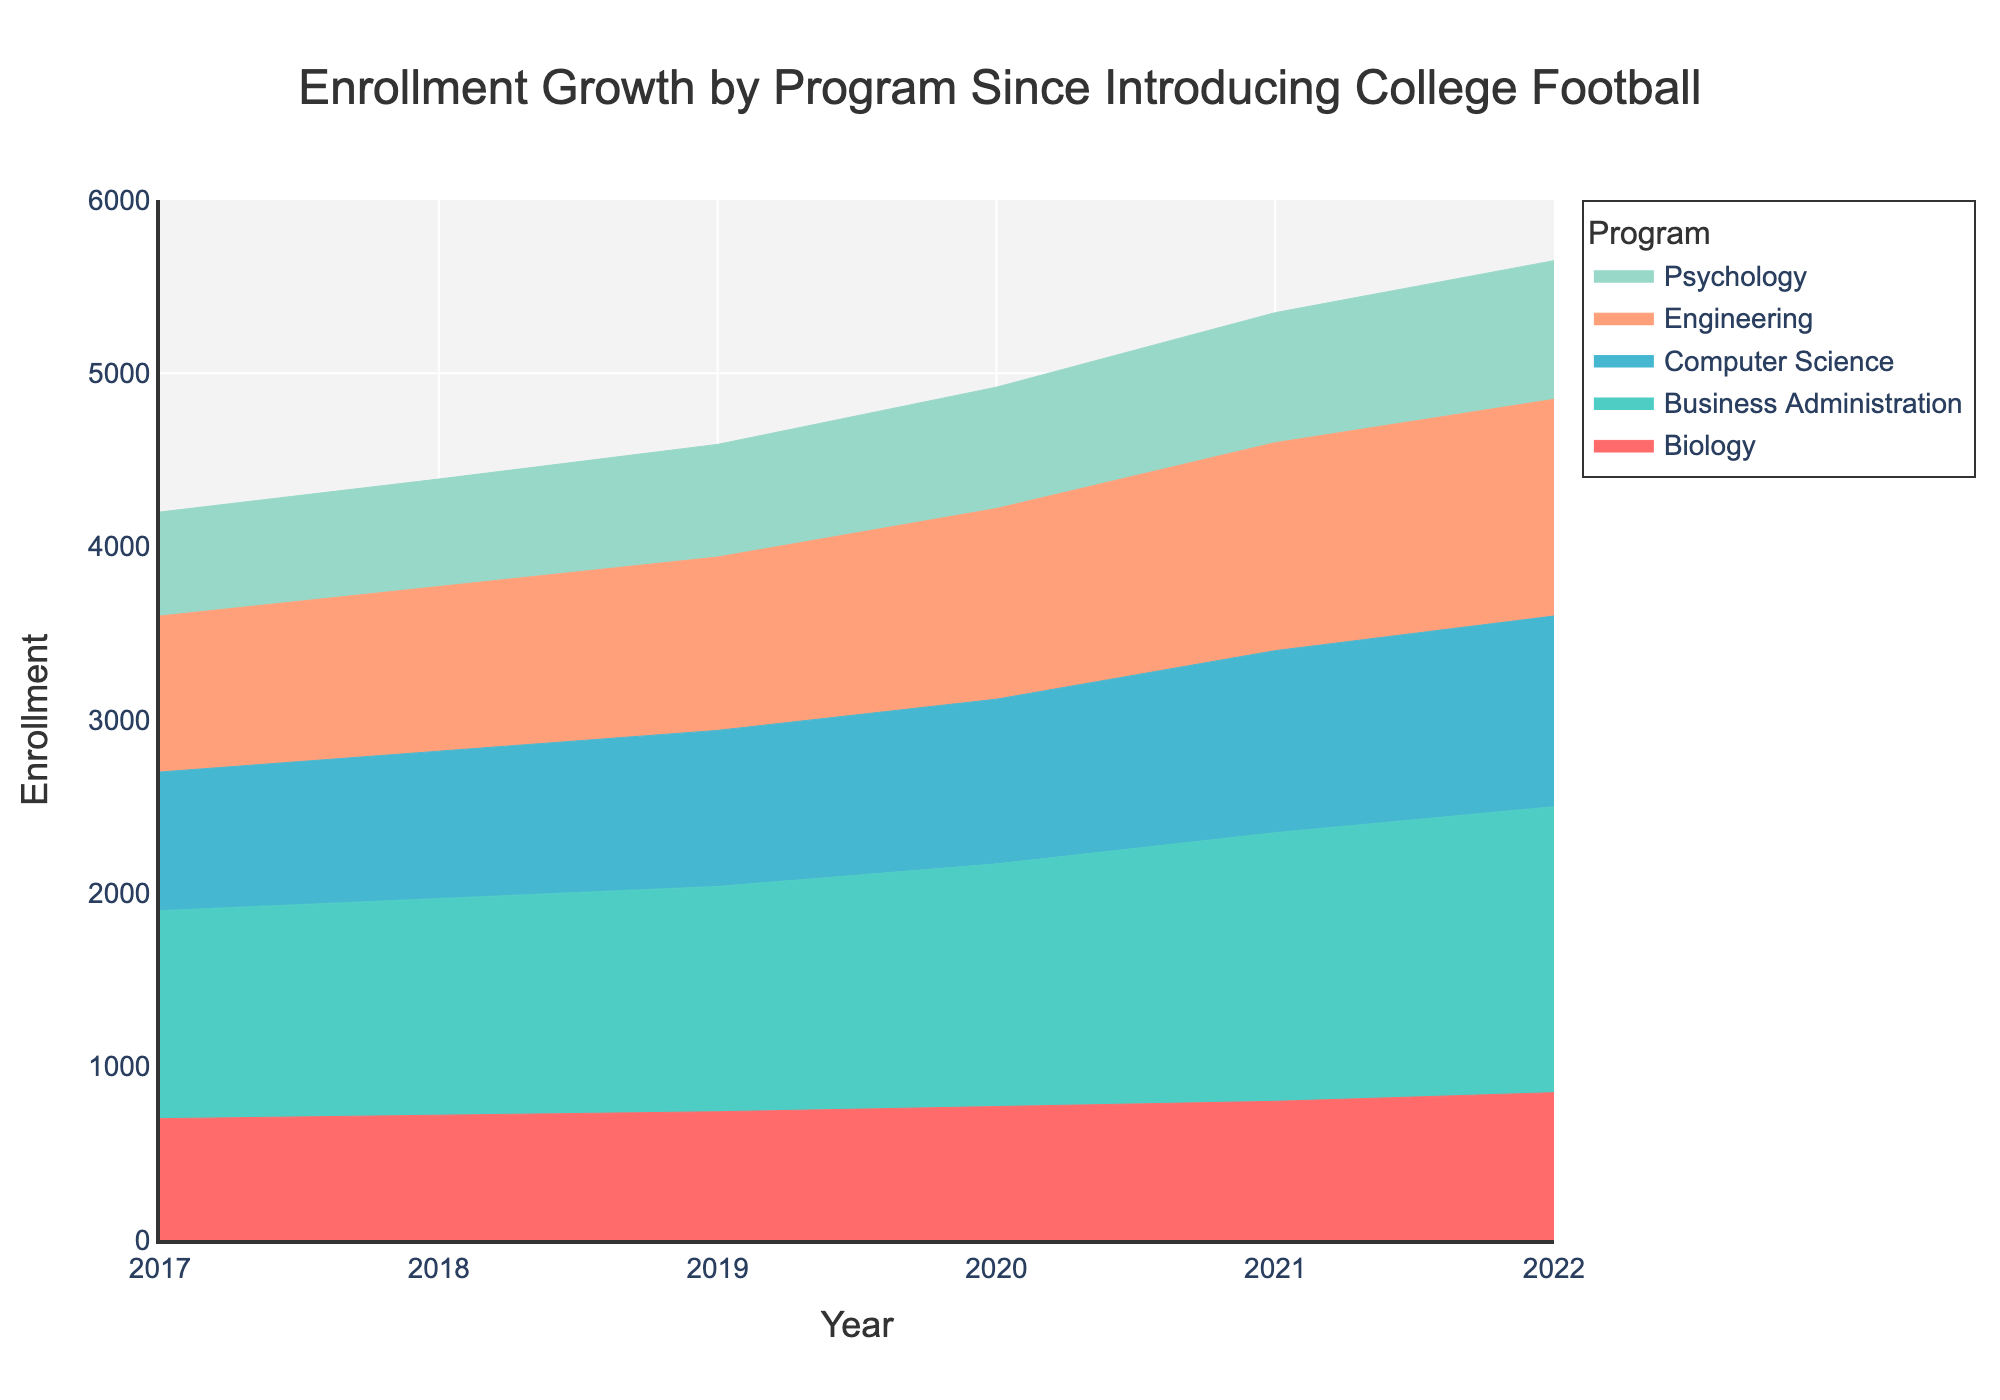What is the title of the plot? The title is usually located at the top of the plot. By reading it, we can determine the overall subject of the plot. The title here is "Enrollment Growth by Program Since Introducing College Football".
Answer: Enrollment Growth by Program Since Introducing College Football What years does the x-axis cover? By examining the x-axis, we can see the range of years covered in the plot. Here, the x-axis ranges from 2017 to 2022.
Answer: 2017 to 2022 Which program had the highest enrollment in 2022? Look at the y-values for the year 2022 on the plot and identify the program with the highest value. The Business Administration program reaches the highest point in 2022.
Answer: Business Administration How has the enrollment for the Psychology program changed from 2017 to 2022? Trace the segment for Psychology from 2017 to 2022 in the area chart. Enrollments rise from 600 to 800 over the years.
Answer: It increased from 600 to 800 Which program shows the most stable (least change) enrollment over the years? To determine this, observe the relative changes in enrollment for each program. The Computer Science program shows the least variation in the plot.
Answer: Computer Science Compare the enrollment growth between Engineering and Biology from 2017 to 2022. Which grew more? By examining the heights of the areas between 2017 and 2022 for both programs, we can see that Engineering grew from 900 to 1250, and Biology from 700 to 850. Hence, Engineering had a greater growth.
Answer: Engineering Which year had the greatest total enrollment for all programs combined? The year with the greatest total enrollment will be indicated by the highest cumulative height of the stacked areas. 2022 has the highest cumulative point on the y-axis.
Answer: 2022 What color represents the Computer Science program in the area chart? By looking at the legend and tracing the corresponding color in the chart, we can see that the Computer Science program is represented by the color teal.
Answer: Teal How much did Business Administration enrollment increase from 2019 to 2020? According to the plot, enrollment for Business Administration increased from 1300 in 2019 to 1400 in 2020. The difference is 1400 - 1300.
Answer: By 100 